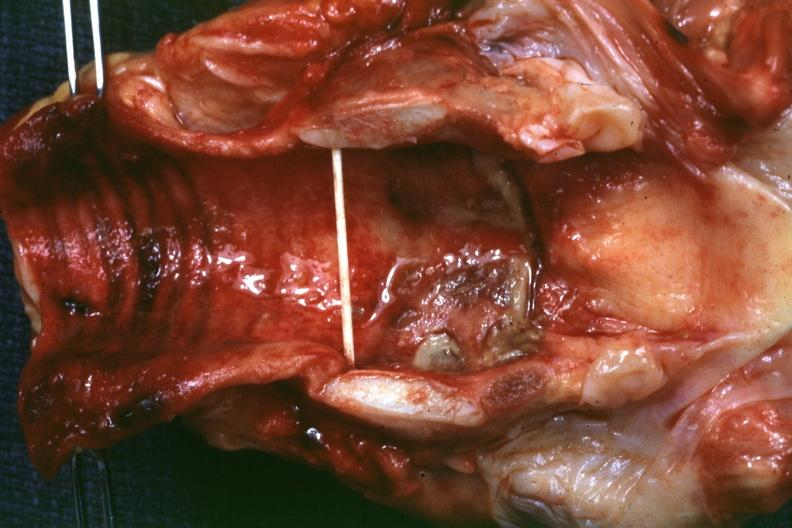where is this?
Answer the question using a single word or phrase. Oral 